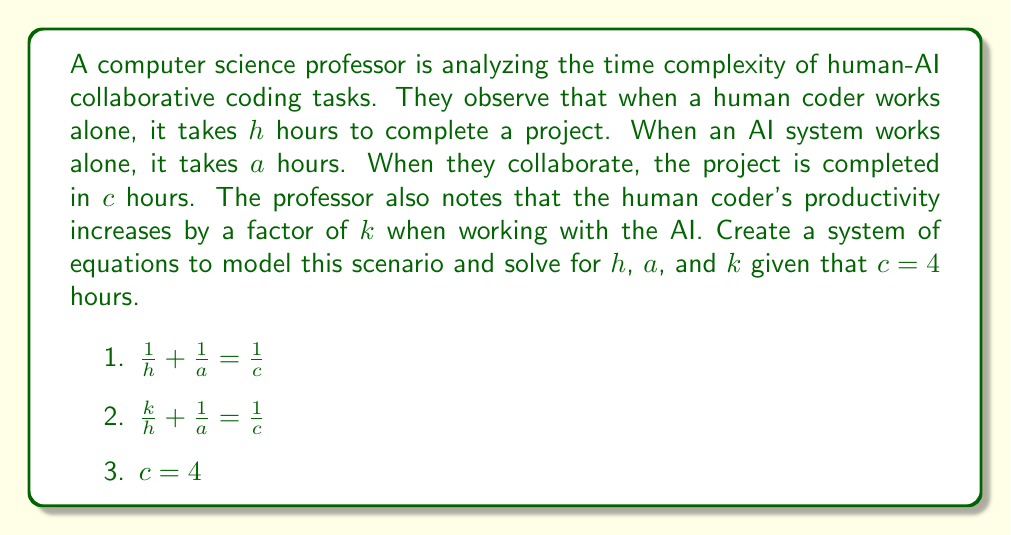Provide a solution to this math problem. To solve this system of equations, we'll follow these steps:

1) First, we'll substitute $c = 4$ into equations 1 and 2:

   $\frac{1}{h} + \frac{1}{a} = \frac{1}{4}$ (Equation 1)
   $\frac{k}{h} + \frac{1}{a} = \frac{1}{4}$ (Equation 2)

2) Subtracting Equation 1 from Equation 2:

   $\frac{k}{h} - \frac{1}{h} = 0$

3) Factoring out $\frac{1}{h}$:

   $\frac{1}{h}(k - 1) = 0$

4) Since $h$ cannot be zero (as it represents time), we can conclude:

   $k - 1 = 0$
   $k = 1$

5) Now, let's substitute $k = 1$ back into Equation 2:

   $\frac{1}{h} + \frac{1}{a} = \frac{1}{4}$

6) This is the same as Equation 1. Let's solve it by first multiplying both sides by $4ha$:

   $4a + 4h = ha$

7) Rearranging:

   $ha - 4h - 4a + 16 = 16$
   $(h - 4)(a - 4) = 16$

8) The only integer solutions for this equation are $h = 8$ and $a = 8$.

Therefore, we have solved for all unknowns: $h = 8$, $a = 8$, and $k = 1$.
Answer: $h = 8$ hours, $a = 8$ hours, $k = 1$ 